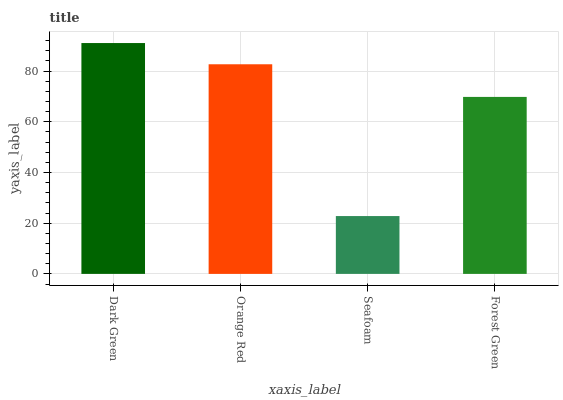Is Seafoam the minimum?
Answer yes or no. Yes. Is Dark Green the maximum?
Answer yes or no. Yes. Is Orange Red the minimum?
Answer yes or no. No. Is Orange Red the maximum?
Answer yes or no. No. Is Dark Green greater than Orange Red?
Answer yes or no. Yes. Is Orange Red less than Dark Green?
Answer yes or no. Yes. Is Orange Red greater than Dark Green?
Answer yes or no. No. Is Dark Green less than Orange Red?
Answer yes or no. No. Is Orange Red the high median?
Answer yes or no. Yes. Is Forest Green the low median?
Answer yes or no. Yes. Is Forest Green the high median?
Answer yes or no. No. Is Seafoam the low median?
Answer yes or no. No. 